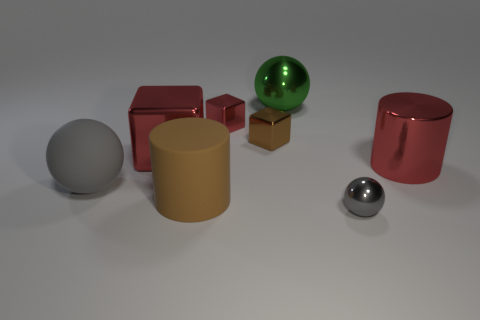Subtract all big gray spheres. How many spheres are left? 2 Subtract all red cylinders. How many gray balls are left? 2 Subtract all brown cubes. How many cubes are left? 2 Add 1 shiny balls. How many objects exist? 9 Subtract all purple spheres. Subtract all green blocks. How many spheres are left? 3 Subtract all cylinders. How many objects are left? 6 Add 8 small shiny blocks. How many small shiny blocks are left? 10 Add 2 small metal things. How many small metal things exist? 5 Subtract 0 gray cylinders. How many objects are left? 8 Subtract all gray balls. Subtract all big matte cylinders. How many objects are left? 5 